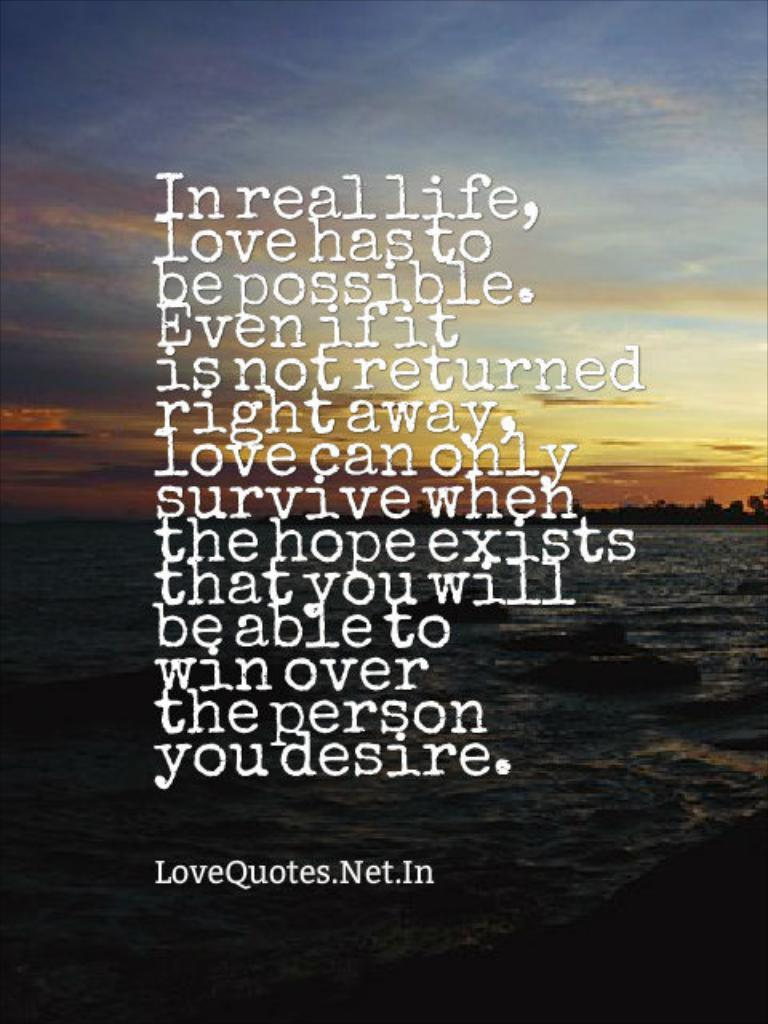<image>
Create a compact narrative representing the image presented. A poem is shown that starts with the phrase in real life. 